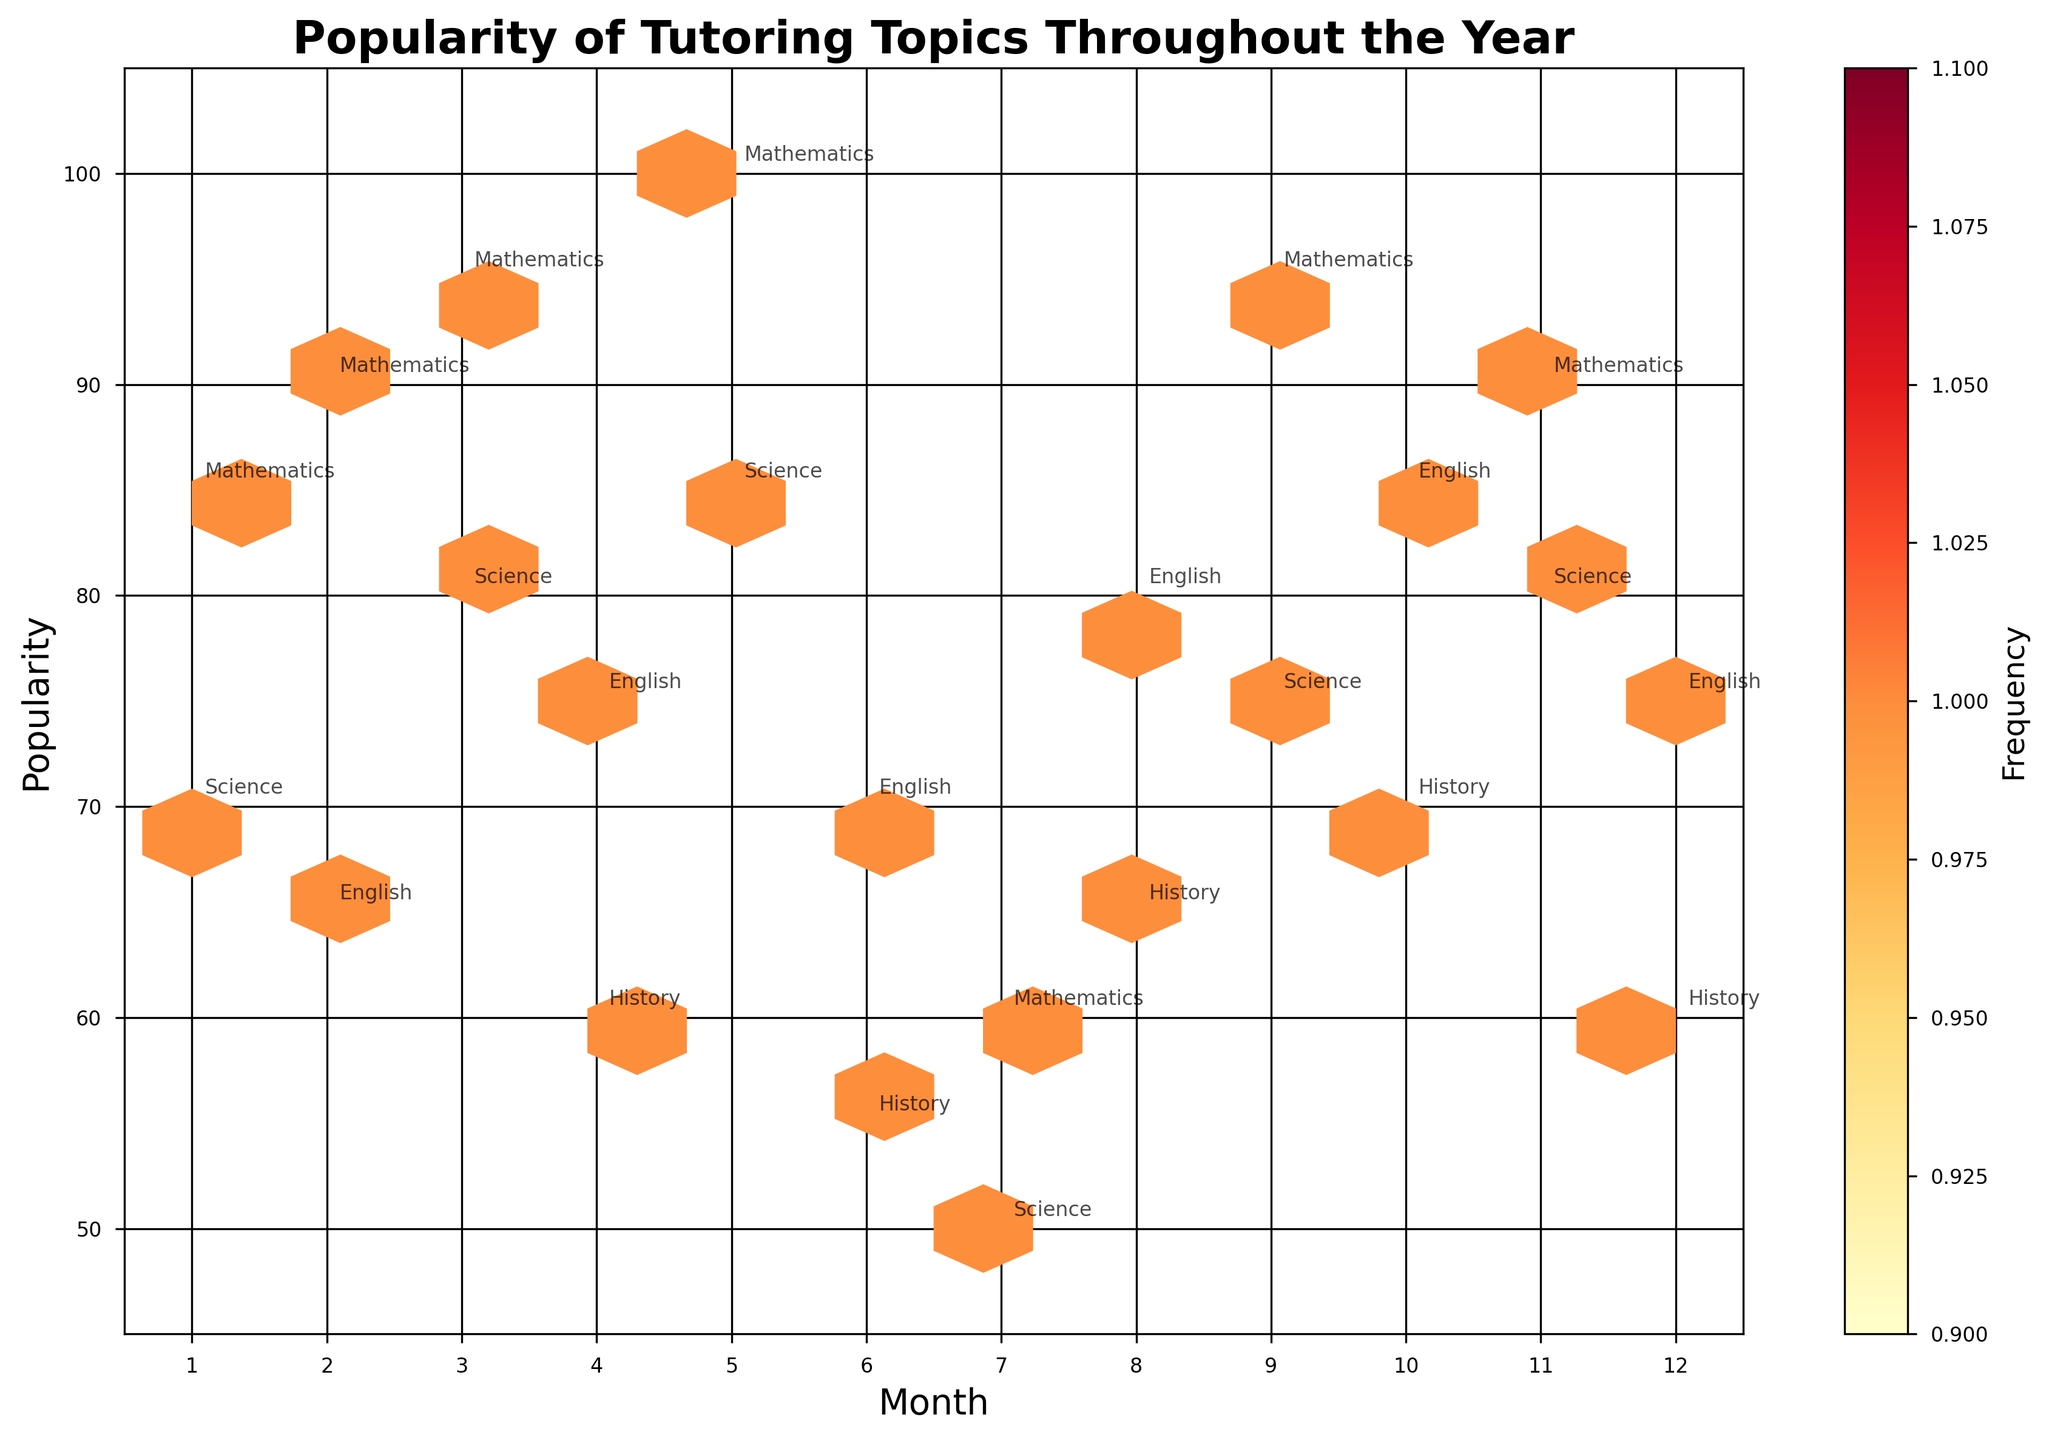What's the title of the plot? The title of the plot is located at the top of the figure and reads "Popularity of Tutoring Topics Throughout the Year".
Answer: Popularity of Tutoring Topics Throughout the Year Which months have the highest popularity for Mathematics? On the plot, specifically look for the month labels on the x-axis and the y-axis values that correspond to Mathematics. The highest popularity values occur in months 3, 5, and 9.
Answer: Months 3, 5, and 9 How does the popularity of Science in October compare with that in November? Locate the months 10 and 11 on the x-axis and observe the y-axis popularity values for Science. In October, the popularity is lower (75) compared to November (80).
Answer: Higher in November Which subject peaks in popularity in January? Look at the month 1 on the x-axis and find the associated subject labels. The subject with the highest popularity here is Mathematics with a value of 85.
Answer: Mathematics What's the average popularity of all subjects in March? Identify the values in March for all subjects: Mathematics (95) and Science (80). Calculate the average by summing these values (95 + 80) and dividing by the number of subjects (2).
Answer: (95 + 80) / 2 = 87.5 During which month is the overall popularity trend the lowest? Examine the hexbin plot across all months, focusing on minimum values. The overall lowest popularity trend occurs in July, with values around 50-60 for Mathematics and Science.
Answer: July Which subject has the highest frequency (density) of its popularity falling within the same range for multiple months? Look for the densest hexagonal bins and observe the subject annotations. Mathematics shows a higher frequency within the high popularity range (85-100) across multiple months.
Answer: Mathematics Compare the trends between Mathematics and History over the year. Examine the popularity values for Mathematics and History over the months. Mathematics consistently shows higher popularity peaking multiple times, while History typically has lower and steadier values.
Answer: Mathematics has higher and more variable popularity Which month has the greatest variation in subject popularity? Identify the months with the widest range on the y-axis for different subjects' values. This is evident in January where Mathematics is at 85 and Science at 70, showing a 15-point difference.
Answer: January 